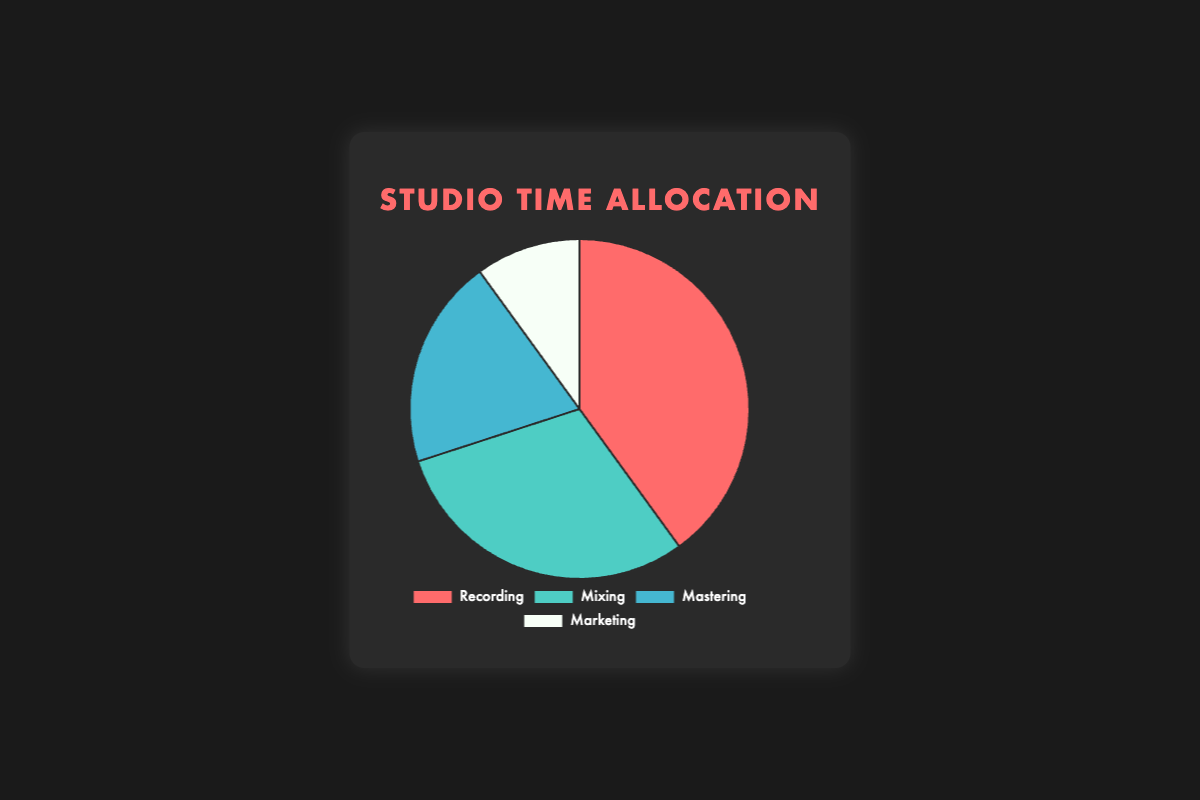What's the most time-consuming activity in the studio? By looking at the figure, the largest segment of the pie represents the activity that consumes the most studio time. Here, it's the red segment representing Recording, which is 40%.
Answer: Recording Which activity takes up the least amount of studio time? The smallest segment of the pie chart indicates the activity with the least time allocation. The white segment representing Marketing, which is 10%, is the smallest.
Answer: Marketing How much more time is spent on Recording compared to Marketing? To find out how much more time is spent on Recording than on Marketing, subtract the percentage of Marketing from the percentage of Recording: 40% - 10% = 30%.
Answer: 30% What is the combined percentage of time spent on Mixing and Mastering? Add the percentages of Mixing and Mastering to find the combined allocation: 30% + 20% = 50%.
Answer: 50% If we were to equally distribute 10% more time among Mixing and Marketing, what would be their new percentages? First, split the additional 10% evenly between Mixing and Marketing, which means each gets 5%. Then add 5% to each activity's original percentage:
Mixing: 30% + 5% = 35%
Marketing: 10% + 5% = 15%
Answer: Mixing: 35%, Marketing: 15% Which two activities combined take up the same percentage of time as Recording? Combine the percentages of Mixing and Mastering to see if their total is equal to Recording’s percentage:
Mixing + Mastering = 30% + 20% = 50%
Since 50% is greater than 40%, let's try another combination: 
Mastering + Marketing = 20% + 10% = 30%
Since 30% is lesser than 40%, try another one:
Mixing + Marketing = 30% + 10% = 40%. This combination matches 40%.
Answer: Mixing and Marketing How much more time is spent on Recording and Mixing together than on Mastering and Marketing together? First, find the sum of the time spent on Recording and Mixing, then on Mastering and Marketing, and finally, find their difference:
Recording + Mixing = 40% + 30% = 70%
Mastering + Marketing = 20% + 10% = 30%
Difference = 70% - 30% = 40%
Answer: 40% What color represents the Mixing segment in the pie chart? By observing the pie chart, the color associated with the Mixing segment can be identified as teal.
Answer: Teal If Marketing were to double its time allocation, how would it compare to the time allocated for Mastering? Doubling Marketing’s current percentage of 10% gives us 20%. This new percentage is then compared with Mastering’s current 20%:
Double of Marketing = 10% * 2 = 20%
Comparison with Mastering = 20% (Marketing) is equal to 20% (Mastering)
Answer: Equal 